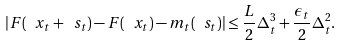Convert formula to latex. <formula><loc_0><loc_0><loc_500><loc_500>| F ( \ x _ { t } + \ s _ { t } ) - F ( \ x _ { t } ) - m _ { t } ( \ s _ { t } ) | \leq \frac { L } { 2 } \Delta _ { t } ^ { 3 } + \frac { \epsilon _ { t } } { 2 } \Delta _ { t } ^ { 2 } .</formula> 